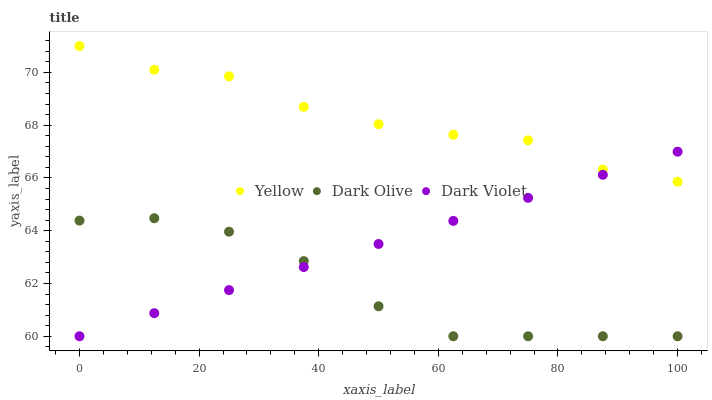Does Dark Olive have the minimum area under the curve?
Answer yes or no. Yes. Does Yellow have the maximum area under the curve?
Answer yes or no. Yes. Does Dark Violet have the minimum area under the curve?
Answer yes or no. No. Does Dark Violet have the maximum area under the curve?
Answer yes or no. No. Is Dark Violet the smoothest?
Answer yes or no. Yes. Is Yellow the roughest?
Answer yes or no. Yes. Is Yellow the smoothest?
Answer yes or no. No. Is Dark Violet the roughest?
Answer yes or no. No. Does Dark Olive have the lowest value?
Answer yes or no. Yes. Does Yellow have the lowest value?
Answer yes or no. No. Does Yellow have the highest value?
Answer yes or no. Yes. Does Dark Violet have the highest value?
Answer yes or no. No. Is Dark Olive less than Yellow?
Answer yes or no. Yes. Is Yellow greater than Dark Olive?
Answer yes or no. Yes. Does Yellow intersect Dark Violet?
Answer yes or no. Yes. Is Yellow less than Dark Violet?
Answer yes or no. No. Is Yellow greater than Dark Violet?
Answer yes or no. No. Does Dark Olive intersect Yellow?
Answer yes or no. No. 